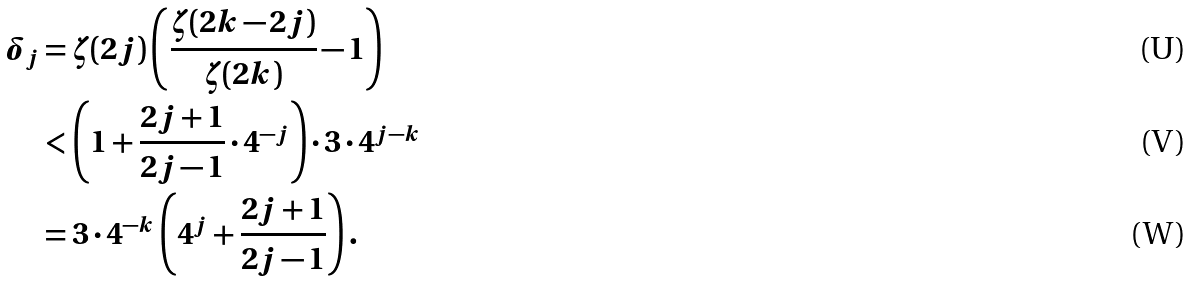<formula> <loc_0><loc_0><loc_500><loc_500>\delta _ { j } & = \zeta ( 2 j ) \left ( \frac { \zeta ( 2 k - 2 j ) } { \zeta ( 2 k ) } - 1 \right ) \\ & < \left ( 1 + \frac { 2 j + 1 } { 2 j - 1 } \cdot 4 ^ { - j } \right ) \cdot 3 \cdot 4 ^ { j - k } \\ & = 3 \cdot 4 ^ { - k } \left ( 4 ^ { j } + \frac { 2 j + 1 } { 2 j - 1 } \right ) .</formula> 